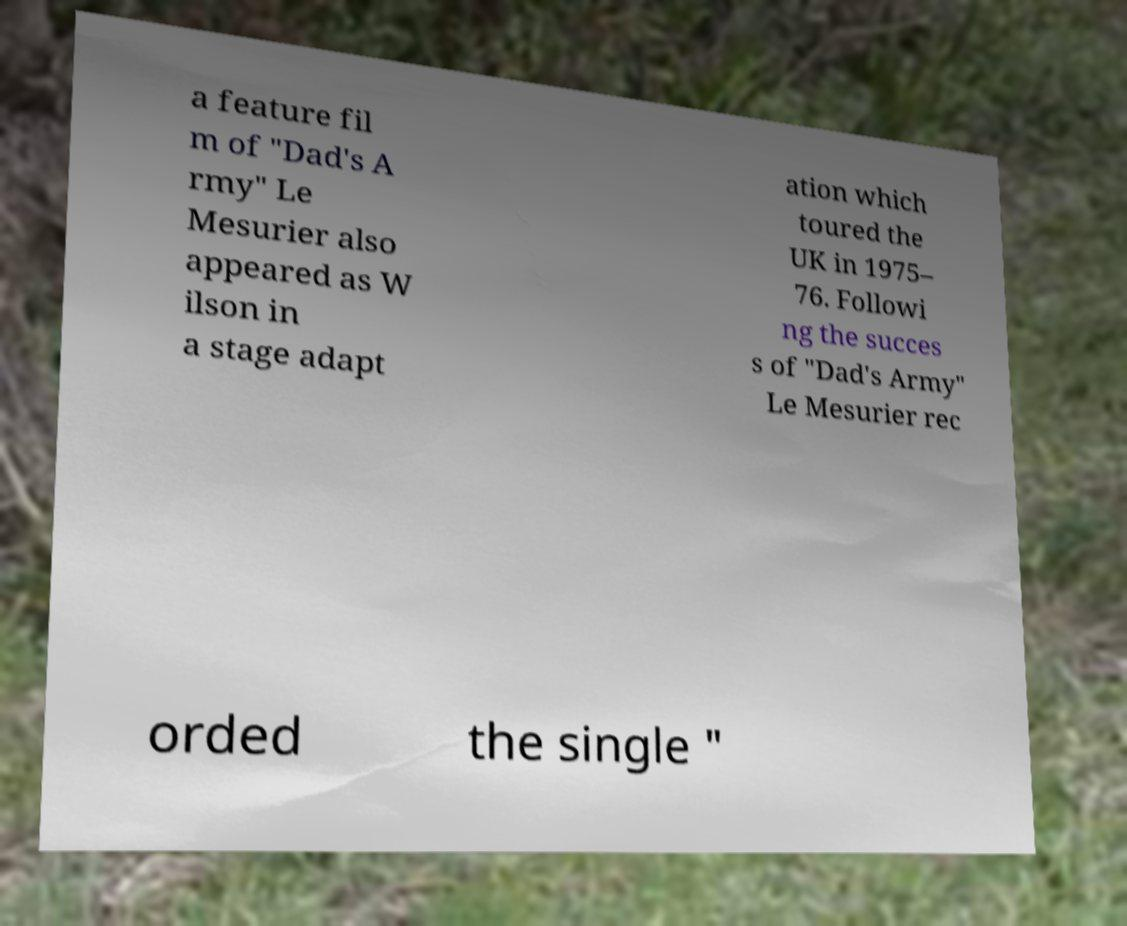There's text embedded in this image that I need extracted. Can you transcribe it verbatim? a feature fil m of "Dad's A rmy" Le Mesurier also appeared as W ilson in a stage adapt ation which toured the UK in 1975– 76. Followi ng the succes s of "Dad's Army" Le Mesurier rec orded the single " 